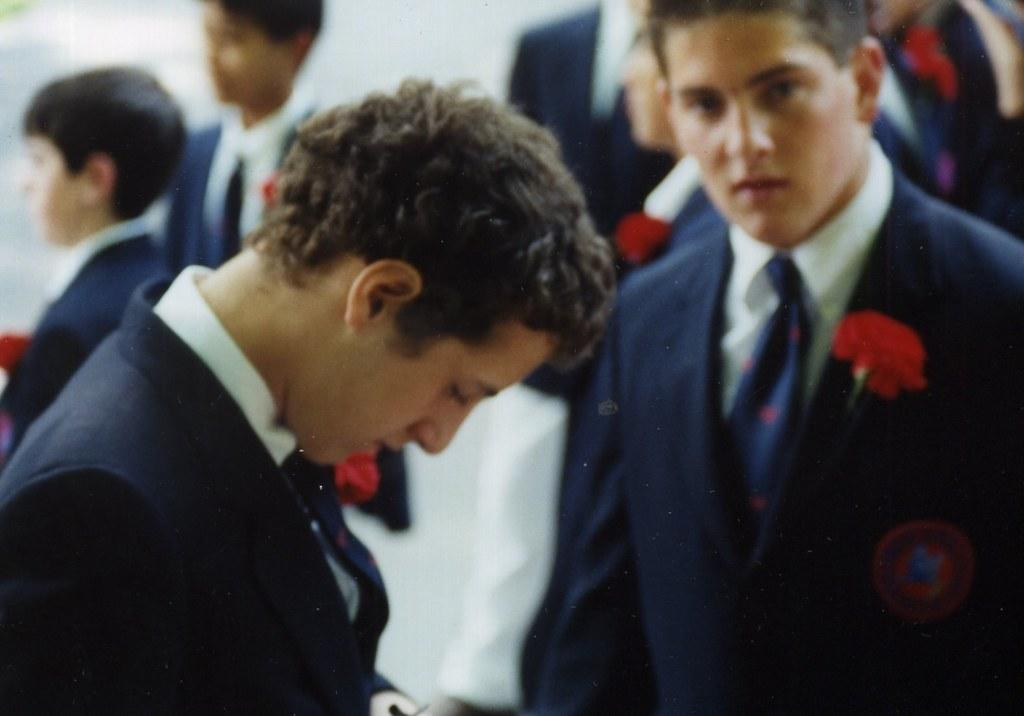What can be seen in the image? There are people standing in the image. What are the people wearing? The people are wearing coats and ties. Are there any additional details about the coats? Yes, there are flowers on the coats. What color are the eyes of the person wearing the skirt in the image? There is no person wearing a skirt in the image, and no one's eyes are visible. 